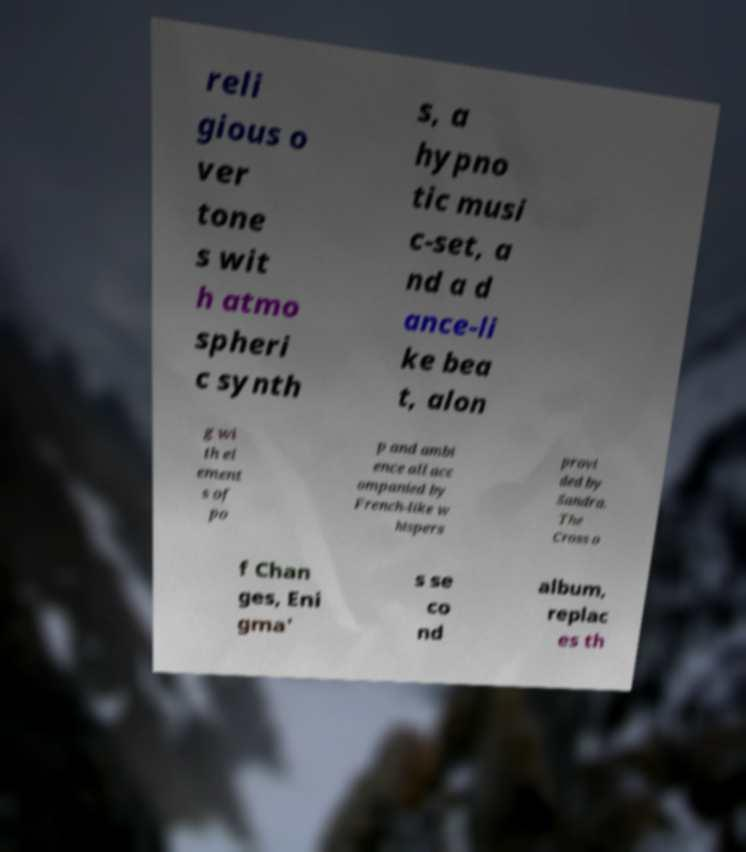What messages or text are displayed in this image? I need them in a readable, typed format. reli gious o ver tone s wit h atmo spheri c synth s, a hypno tic musi c-set, a nd a d ance-li ke bea t, alon g wi th el ement s of po p and ambi ence all acc ompanied by French-like w hispers provi ded by Sandra. The Cross o f Chan ges, Eni gma' s se co nd album, replac es th 